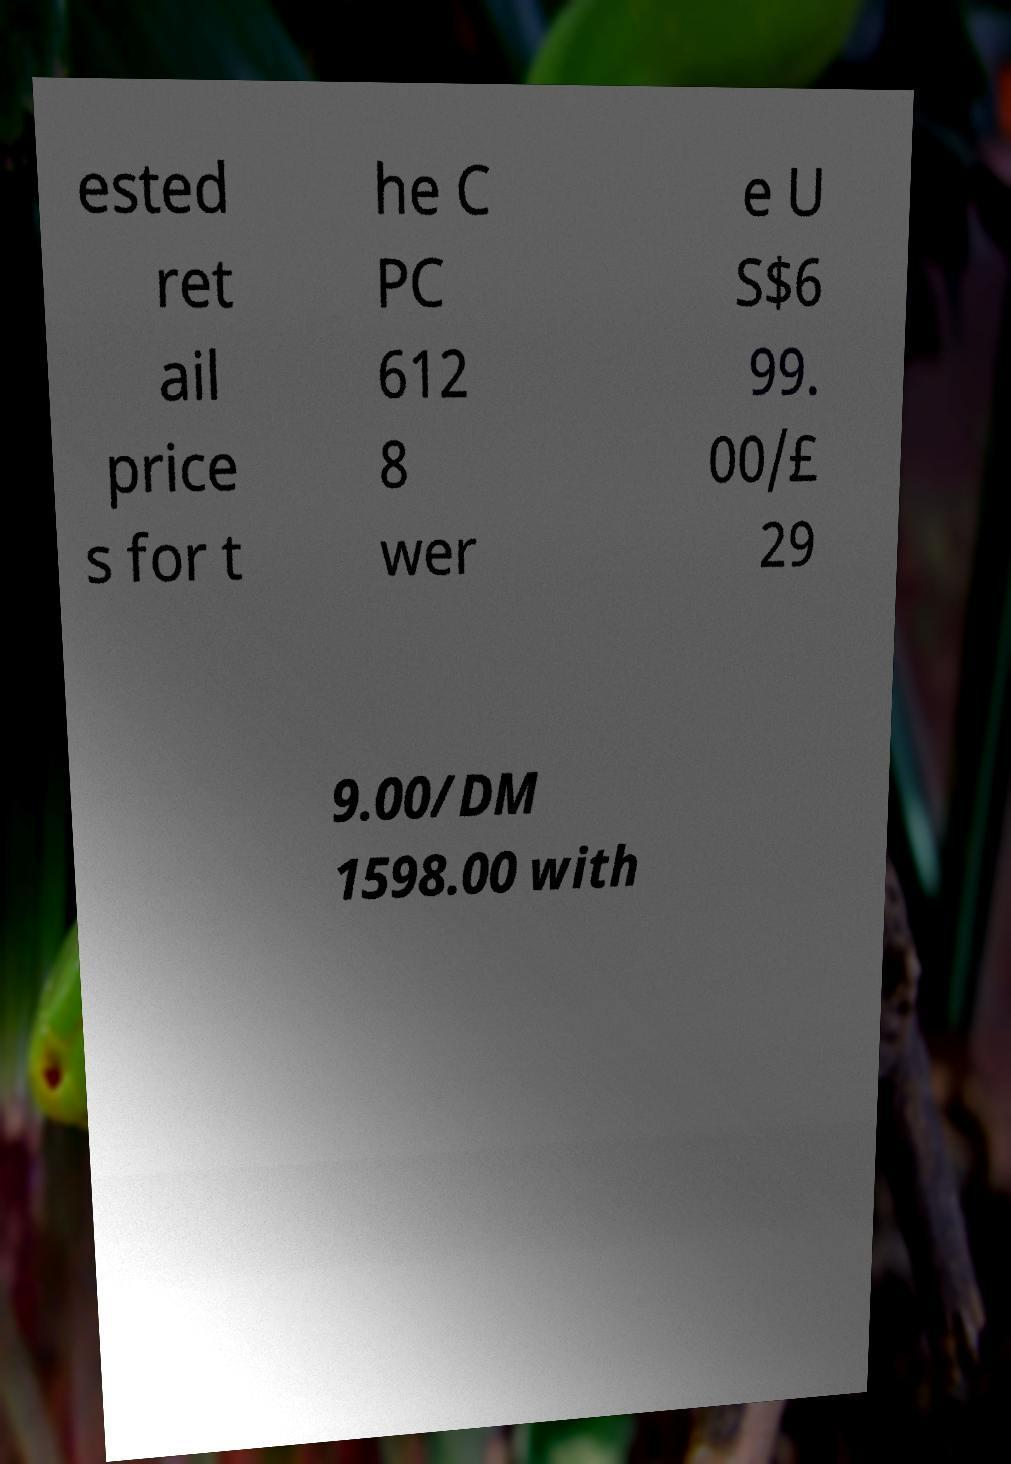For documentation purposes, I need the text within this image transcribed. Could you provide that? ested ret ail price s for t he C PC 612 8 wer e U S$6 99. 00/£ 29 9.00/DM 1598.00 with 